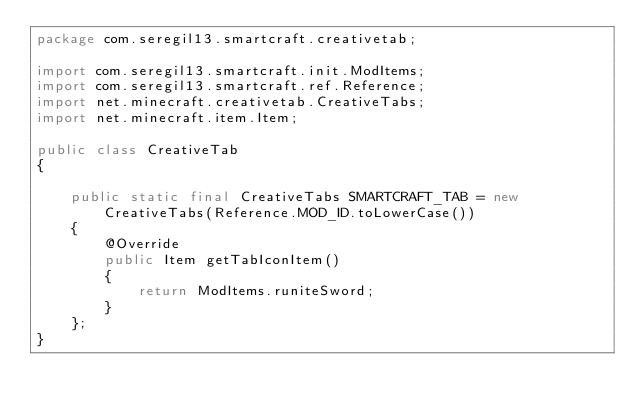Convert code to text. <code><loc_0><loc_0><loc_500><loc_500><_Java_>package com.seregil13.smartcraft.creativetab;

import com.seregil13.smartcraft.init.ModItems;
import com.seregil13.smartcraft.ref.Reference;
import net.minecraft.creativetab.CreativeTabs;
import net.minecraft.item.Item;

public class CreativeTab
{

    public static final CreativeTabs SMARTCRAFT_TAB = new CreativeTabs(Reference.MOD_ID.toLowerCase())
    {
        @Override
        public Item getTabIconItem()
        {
            return ModItems.runiteSword;
        }
    };
}
</code> 